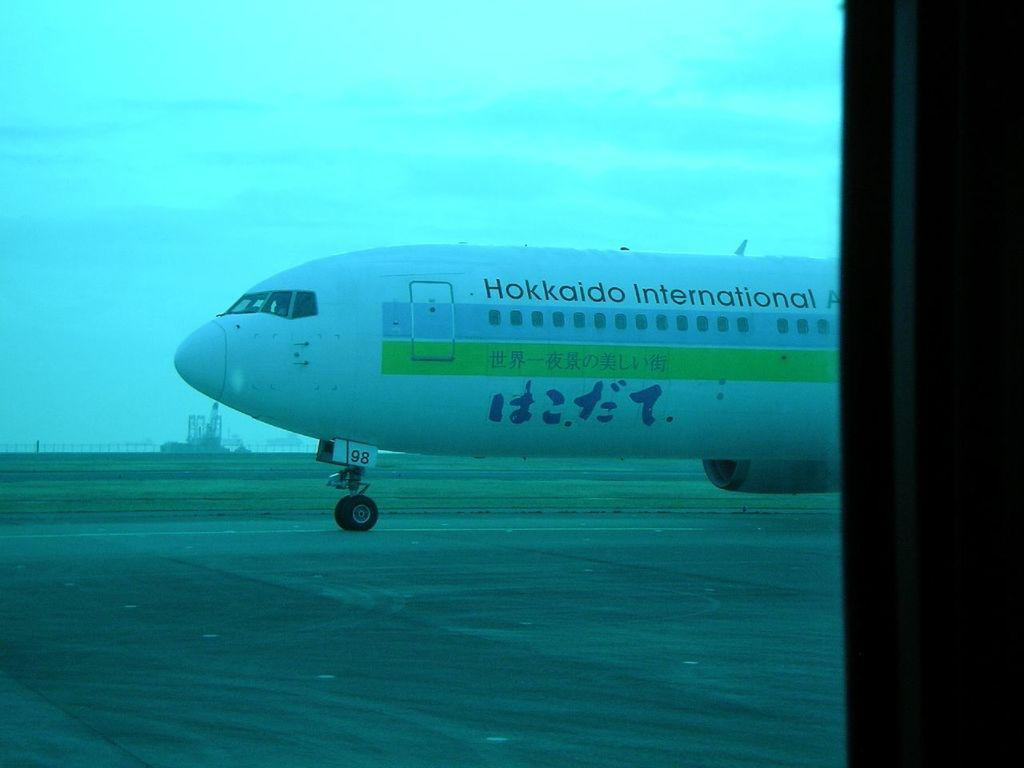What is the main subject of the image? The main subject of the image is an airplane. Where is the airplane located in the image? The airplane is on a runway. What can be seen in the background of the image? There is green grass visible in the background. What is visible in the sky in the image? There are clouds in the sky. Can you tell me how many straws are on the airplane in the image? There are no straws present on the airplane in the image. What type of cherry is being used as a prop in the image? There is no cherry present in the image. 